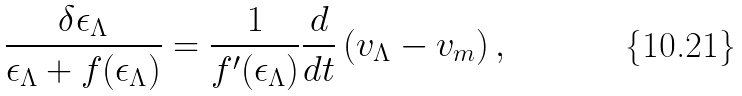<formula> <loc_0><loc_0><loc_500><loc_500>\frac { \delta \epsilon _ { \Lambda } } { \epsilon _ { \Lambda } + f ( \epsilon _ { \Lambda } ) } = \frac { 1 } { f ^ { \prime } ( \epsilon _ { \Lambda } ) } \frac { d } { d t } \left ( v _ { \Lambda } - v _ { m } \right ) ,</formula> 